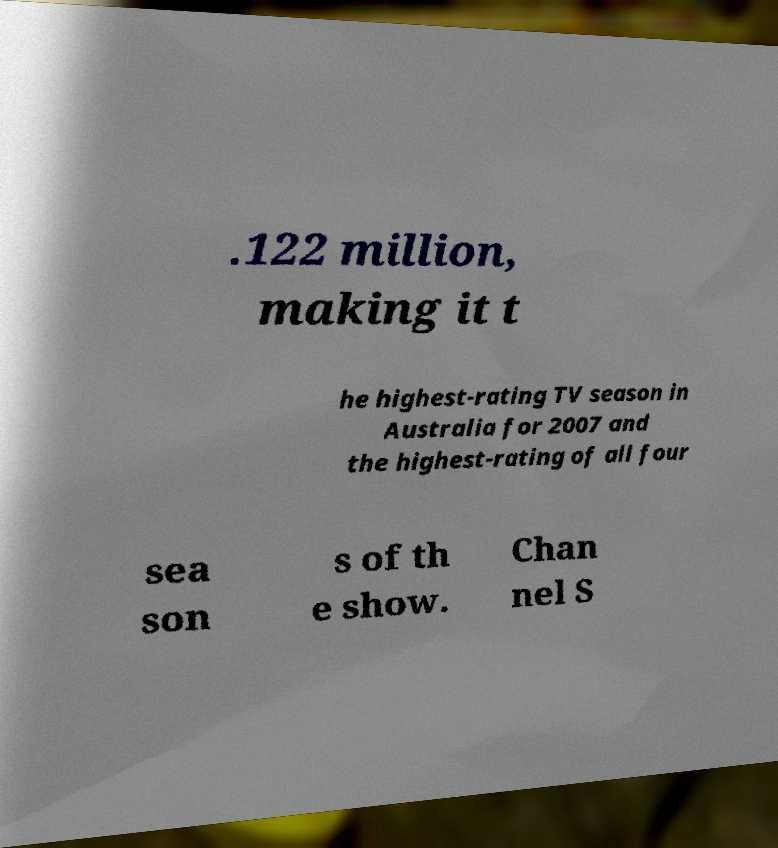Could you extract and type out the text from this image? .122 million, making it t he highest-rating TV season in Australia for 2007 and the highest-rating of all four sea son s of th e show. Chan nel S 